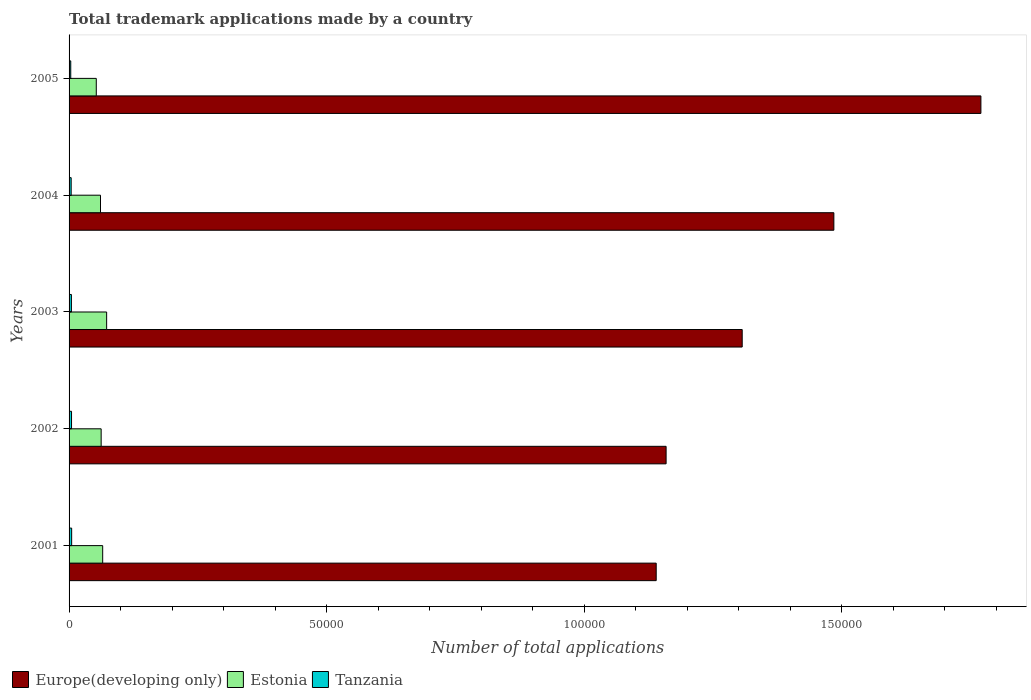How many different coloured bars are there?
Your answer should be compact. 3. How many groups of bars are there?
Give a very brief answer. 5. Are the number of bars per tick equal to the number of legend labels?
Give a very brief answer. Yes. What is the number of applications made by in Europe(developing only) in 2001?
Ensure brevity in your answer.  1.14e+05. Across all years, what is the maximum number of applications made by in Estonia?
Your answer should be very brief. 7292. Across all years, what is the minimum number of applications made by in Tanzania?
Offer a terse response. 325. In which year was the number of applications made by in Europe(developing only) minimum?
Your response must be concise. 2001. What is the total number of applications made by in Tanzania in the graph?
Offer a terse response. 2165. What is the difference between the number of applications made by in Tanzania in 2001 and that in 2004?
Your answer should be compact. 94. What is the difference between the number of applications made by in Tanzania in 2003 and the number of applications made by in Estonia in 2002?
Your response must be concise. -5778. What is the average number of applications made by in Estonia per year?
Provide a short and direct response. 6286. In the year 2002, what is the difference between the number of applications made by in Tanzania and number of applications made by in Estonia?
Your response must be concise. -5752. In how many years, is the number of applications made by in Estonia greater than 130000 ?
Give a very brief answer. 0. What is the ratio of the number of applications made by in Tanzania in 2001 to that in 2003?
Make the answer very short. 1.11. Is the number of applications made by in Estonia in 2004 less than that in 2005?
Keep it short and to the point. No. Is the difference between the number of applications made by in Tanzania in 2001 and 2002 greater than the difference between the number of applications made by in Estonia in 2001 and 2002?
Your response must be concise. No. What is the difference between the highest and the second highest number of applications made by in Tanzania?
Offer a terse response. 24. What is the difference between the highest and the lowest number of applications made by in Estonia?
Provide a short and direct response. 2011. In how many years, is the number of applications made by in Tanzania greater than the average number of applications made by in Tanzania taken over all years?
Your response must be concise. 3. Is the sum of the number of applications made by in Europe(developing only) in 2003 and 2004 greater than the maximum number of applications made by in Estonia across all years?
Ensure brevity in your answer.  Yes. What does the 1st bar from the top in 2005 represents?
Keep it short and to the point. Tanzania. What does the 2nd bar from the bottom in 2005 represents?
Offer a very short reply. Estonia. Is it the case that in every year, the sum of the number of applications made by in Tanzania and number of applications made by in Estonia is greater than the number of applications made by in Europe(developing only)?
Give a very brief answer. No. What is the difference between two consecutive major ticks on the X-axis?
Provide a succinct answer. 5.00e+04. Does the graph contain any zero values?
Offer a terse response. No. Where does the legend appear in the graph?
Ensure brevity in your answer.  Bottom left. What is the title of the graph?
Provide a short and direct response. Total trademark applications made by a country. Does "Small states" appear as one of the legend labels in the graph?
Make the answer very short. No. What is the label or title of the X-axis?
Ensure brevity in your answer.  Number of total applications. What is the Number of total applications of Europe(developing only) in 2001?
Your response must be concise. 1.14e+05. What is the Number of total applications in Estonia in 2001?
Offer a terse response. 6527. What is the Number of total applications in Tanzania in 2001?
Give a very brief answer. 502. What is the Number of total applications of Europe(developing only) in 2002?
Your answer should be compact. 1.16e+05. What is the Number of total applications of Estonia in 2002?
Provide a succinct answer. 6230. What is the Number of total applications in Tanzania in 2002?
Ensure brevity in your answer.  478. What is the Number of total applications in Europe(developing only) in 2003?
Offer a terse response. 1.31e+05. What is the Number of total applications of Estonia in 2003?
Give a very brief answer. 7292. What is the Number of total applications in Tanzania in 2003?
Keep it short and to the point. 452. What is the Number of total applications in Europe(developing only) in 2004?
Ensure brevity in your answer.  1.48e+05. What is the Number of total applications of Estonia in 2004?
Give a very brief answer. 6100. What is the Number of total applications in Tanzania in 2004?
Ensure brevity in your answer.  408. What is the Number of total applications in Europe(developing only) in 2005?
Make the answer very short. 1.77e+05. What is the Number of total applications of Estonia in 2005?
Make the answer very short. 5281. What is the Number of total applications in Tanzania in 2005?
Your answer should be compact. 325. Across all years, what is the maximum Number of total applications in Europe(developing only)?
Offer a terse response. 1.77e+05. Across all years, what is the maximum Number of total applications in Estonia?
Provide a succinct answer. 7292. Across all years, what is the maximum Number of total applications of Tanzania?
Make the answer very short. 502. Across all years, what is the minimum Number of total applications in Europe(developing only)?
Your answer should be compact. 1.14e+05. Across all years, what is the minimum Number of total applications in Estonia?
Provide a short and direct response. 5281. Across all years, what is the minimum Number of total applications of Tanzania?
Keep it short and to the point. 325. What is the total Number of total applications of Europe(developing only) in the graph?
Your response must be concise. 6.86e+05. What is the total Number of total applications of Estonia in the graph?
Your response must be concise. 3.14e+04. What is the total Number of total applications of Tanzania in the graph?
Your answer should be very brief. 2165. What is the difference between the Number of total applications of Europe(developing only) in 2001 and that in 2002?
Give a very brief answer. -1922. What is the difference between the Number of total applications in Estonia in 2001 and that in 2002?
Make the answer very short. 297. What is the difference between the Number of total applications of Tanzania in 2001 and that in 2002?
Your answer should be compact. 24. What is the difference between the Number of total applications in Europe(developing only) in 2001 and that in 2003?
Give a very brief answer. -1.67e+04. What is the difference between the Number of total applications in Estonia in 2001 and that in 2003?
Make the answer very short. -765. What is the difference between the Number of total applications in Tanzania in 2001 and that in 2003?
Provide a short and direct response. 50. What is the difference between the Number of total applications of Europe(developing only) in 2001 and that in 2004?
Give a very brief answer. -3.45e+04. What is the difference between the Number of total applications of Estonia in 2001 and that in 2004?
Provide a succinct answer. 427. What is the difference between the Number of total applications in Tanzania in 2001 and that in 2004?
Offer a terse response. 94. What is the difference between the Number of total applications of Europe(developing only) in 2001 and that in 2005?
Provide a short and direct response. -6.30e+04. What is the difference between the Number of total applications in Estonia in 2001 and that in 2005?
Your answer should be very brief. 1246. What is the difference between the Number of total applications of Tanzania in 2001 and that in 2005?
Give a very brief answer. 177. What is the difference between the Number of total applications in Europe(developing only) in 2002 and that in 2003?
Give a very brief answer. -1.48e+04. What is the difference between the Number of total applications in Estonia in 2002 and that in 2003?
Keep it short and to the point. -1062. What is the difference between the Number of total applications of Tanzania in 2002 and that in 2003?
Your answer should be very brief. 26. What is the difference between the Number of total applications of Europe(developing only) in 2002 and that in 2004?
Provide a succinct answer. -3.26e+04. What is the difference between the Number of total applications in Estonia in 2002 and that in 2004?
Offer a terse response. 130. What is the difference between the Number of total applications of Tanzania in 2002 and that in 2004?
Offer a terse response. 70. What is the difference between the Number of total applications of Europe(developing only) in 2002 and that in 2005?
Offer a very short reply. -6.11e+04. What is the difference between the Number of total applications of Estonia in 2002 and that in 2005?
Offer a very short reply. 949. What is the difference between the Number of total applications in Tanzania in 2002 and that in 2005?
Ensure brevity in your answer.  153. What is the difference between the Number of total applications in Europe(developing only) in 2003 and that in 2004?
Offer a very short reply. -1.78e+04. What is the difference between the Number of total applications of Estonia in 2003 and that in 2004?
Give a very brief answer. 1192. What is the difference between the Number of total applications in Europe(developing only) in 2003 and that in 2005?
Offer a very short reply. -4.63e+04. What is the difference between the Number of total applications in Estonia in 2003 and that in 2005?
Provide a short and direct response. 2011. What is the difference between the Number of total applications of Tanzania in 2003 and that in 2005?
Offer a very short reply. 127. What is the difference between the Number of total applications of Europe(developing only) in 2004 and that in 2005?
Offer a terse response. -2.85e+04. What is the difference between the Number of total applications in Estonia in 2004 and that in 2005?
Offer a very short reply. 819. What is the difference between the Number of total applications in Europe(developing only) in 2001 and the Number of total applications in Estonia in 2002?
Your answer should be very brief. 1.08e+05. What is the difference between the Number of total applications in Europe(developing only) in 2001 and the Number of total applications in Tanzania in 2002?
Keep it short and to the point. 1.13e+05. What is the difference between the Number of total applications of Estonia in 2001 and the Number of total applications of Tanzania in 2002?
Ensure brevity in your answer.  6049. What is the difference between the Number of total applications of Europe(developing only) in 2001 and the Number of total applications of Estonia in 2003?
Your response must be concise. 1.07e+05. What is the difference between the Number of total applications of Europe(developing only) in 2001 and the Number of total applications of Tanzania in 2003?
Your response must be concise. 1.14e+05. What is the difference between the Number of total applications of Estonia in 2001 and the Number of total applications of Tanzania in 2003?
Give a very brief answer. 6075. What is the difference between the Number of total applications in Europe(developing only) in 2001 and the Number of total applications in Estonia in 2004?
Your answer should be compact. 1.08e+05. What is the difference between the Number of total applications in Europe(developing only) in 2001 and the Number of total applications in Tanzania in 2004?
Ensure brevity in your answer.  1.14e+05. What is the difference between the Number of total applications in Estonia in 2001 and the Number of total applications in Tanzania in 2004?
Keep it short and to the point. 6119. What is the difference between the Number of total applications in Europe(developing only) in 2001 and the Number of total applications in Estonia in 2005?
Provide a short and direct response. 1.09e+05. What is the difference between the Number of total applications of Europe(developing only) in 2001 and the Number of total applications of Tanzania in 2005?
Offer a very short reply. 1.14e+05. What is the difference between the Number of total applications in Estonia in 2001 and the Number of total applications in Tanzania in 2005?
Offer a very short reply. 6202. What is the difference between the Number of total applications in Europe(developing only) in 2002 and the Number of total applications in Estonia in 2003?
Your answer should be very brief. 1.09e+05. What is the difference between the Number of total applications of Europe(developing only) in 2002 and the Number of total applications of Tanzania in 2003?
Offer a terse response. 1.15e+05. What is the difference between the Number of total applications of Estonia in 2002 and the Number of total applications of Tanzania in 2003?
Provide a short and direct response. 5778. What is the difference between the Number of total applications of Europe(developing only) in 2002 and the Number of total applications of Estonia in 2004?
Offer a terse response. 1.10e+05. What is the difference between the Number of total applications of Europe(developing only) in 2002 and the Number of total applications of Tanzania in 2004?
Provide a succinct answer. 1.15e+05. What is the difference between the Number of total applications of Estonia in 2002 and the Number of total applications of Tanzania in 2004?
Provide a short and direct response. 5822. What is the difference between the Number of total applications in Europe(developing only) in 2002 and the Number of total applications in Estonia in 2005?
Ensure brevity in your answer.  1.11e+05. What is the difference between the Number of total applications of Europe(developing only) in 2002 and the Number of total applications of Tanzania in 2005?
Give a very brief answer. 1.16e+05. What is the difference between the Number of total applications of Estonia in 2002 and the Number of total applications of Tanzania in 2005?
Make the answer very short. 5905. What is the difference between the Number of total applications of Europe(developing only) in 2003 and the Number of total applications of Estonia in 2004?
Keep it short and to the point. 1.25e+05. What is the difference between the Number of total applications of Europe(developing only) in 2003 and the Number of total applications of Tanzania in 2004?
Provide a short and direct response. 1.30e+05. What is the difference between the Number of total applications of Estonia in 2003 and the Number of total applications of Tanzania in 2004?
Give a very brief answer. 6884. What is the difference between the Number of total applications of Europe(developing only) in 2003 and the Number of total applications of Estonia in 2005?
Your answer should be very brief. 1.25e+05. What is the difference between the Number of total applications in Europe(developing only) in 2003 and the Number of total applications in Tanzania in 2005?
Give a very brief answer. 1.30e+05. What is the difference between the Number of total applications of Estonia in 2003 and the Number of total applications of Tanzania in 2005?
Provide a short and direct response. 6967. What is the difference between the Number of total applications in Europe(developing only) in 2004 and the Number of total applications in Estonia in 2005?
Your answer should be very brief. 1.43e+05. What is the difference between the Number of total applications in Europe(developing only) in 2004 and the Number of total applications in Tanzania in 2005?
Offer a very short reply. 1.48e+05. What is the difference between the Number of total applications of Estonia in 2004 and the Number of total applications of Tanzania in 2005?
Keep it short and to the point. 5775. What is the average Number of total applications in Europe(developing only) per year?
Your answer should be very brief. 1.37e+05. What is the average Number of total applications of Estonia per year?
Your answer should be very brief. 6286. What is the average Number of total applications of Tanzania per year?
Your response must be concise. 433. In the year 2001, what is the difference between the Number of total applications of Europe(developing only) and Number of total applications of Estonia?
Your response must be concise. 1.07e+05. In the year 2001, what is the difference between the Number of total applications of Europe(developing only) and Number of total applications of Tanzania?
Your answer should be compact. 1.13e+05. In the year 2001, what is the difference between the Number of total applications in Estonia and Number of total applications in Tanzania?
Give a very brief answer. 6025. In the year 2002, what is the difference between the Number of total applications of Europe(developing only) and Number of total applications of Estonia?
Your response must be concise. 1.10e+05. In the year 2002, what is the difference between the Number of total applications in Europe(developing only) and Number of total applications in Tanzania?
Keep it short and to the point. 1.15e+05. In the year 2002, what is the difference between the Number of total applications of Estonia and Number of total applications of Tanzania?
Keep it short and to the point. 5752. In the year 2003, what is the difference between the Number of total applications of Europe(developing only) and Number of total applications of Estonia?
Your response must be concise. 1.23e+05. In the year 2003, what is the difference between the Number of total applications in Europe(developing only) and Number of total applications in Tanzania?
Provide a succinct answer. 1.30e+05. In the year 2003, what is the difference between the Number of total applications of Estonia and Number of total applications of Tanzania?
Provide a short and direct response. 6840. In the year 2004, what is the difference between the Number of total applications in Europe(developing only) and Number of total applications in Estonia?
Ensure brevity in your answer.  1.42e+05. In the year 2004, what is the difference between the Number of total applications of Europe(developing only) and Number of total applications of Tanzania?
Your answer should be very brief. 1.48e+05. In the year 2004, what is the difference between the Number of total applications of Estonia and Number of total applications of Tanzania?
Provide a succinct answer. 5692. In the year 2005, what is the difference between the Number of total applications in Europe(developing only) and Number of total applications in Estonia?
Your answer should be compact. 1.72e+05. In the year 2005, what is the difference between the Number of total applications of Europe(developing only) and Number of total applications of Tanzania?
Give a very brief answer. 1.77e+05. In the year 2005, what is the difference between the Number of total applications of Estonia and Number of total applications of Tanzania?
Your response must be concise. 4956. What is the ratio of the Number of total applications in Europe(developing only) in 2001 to that in 2002?
Your answer should be compact. 0.98. What is the ratio of the Number of total applications in Estonia in 2001 to that in 2002?
Ensure brevity in your answer.  1.05. What is the ratio of the Number of total applications of Tanzania in 2001 to that in 2002?
Offer a very short reply. 1.05. What is the ratio of the Number of total applications in Europe(developing only) in 2001 to that in 2003?
Give a very brief answer. 0.87. What is the ratio of the Number of total applications in Estonia in 2001 to that in 2003?
Make the answer very short. 0.9. What is the ratio of the Number of total applications of Tanzania in 2001 to that in 2003?
Give a very brief answer. 1.11. What is the ratio of the Number of total applications in Europe(developing only) in 2001 to that in 2004?
Make the answer very short. 0.77. What is the ratio of the Number of total applications in Estonia in 2001 to that in 2004?
Your answer should be very brief. 1.07. What is the ratio of the Number of total applications of Tanzania in 2001 to that in 2004?
Provide a succinct answer. 1.23. What is the ratio of the Number of total applications in Europe(developing only) in 2001 to that in 2005?
Make the answer very short. 0.64. What is the ratio of the Number of total applications in Estonia in 2001 to that in 2005?
Give a very brief answer. 1.24. What is the ratio of the Number of total applications in Tanzania in 2001 to that in 2005?
Your answer should be very brief. 1.54. What is the ratio of the Number of total applications of Europe(developing only) in 2002 to that in 2003?
Offer a very short reply. 0.89. What is the ratio of the Number of total applications of Estonia in 2002 to that in 2003?
Your answer should be very brief. 0.85. What is the ratio of the Number of total applications in Tanzania in 2002 to that in 2003?
Your answer should be compact. 1.06. What is the ratio of the Number of total applications in Europe(developing only) in 2002 to that in 2004?
Give a very brief answer. 0.78. What is the ratio of the Number of total applications of Estonia in 2002 to that in 2004?
Offer a terse response. 1.02. What is the ratio of the Number of total applications of Tanzania in 2002 to that in 2004?
Provide a short and direct response. 1.17. What is the ratio of the Number of total applications in Europe(developing only) in 2002 to that in 2005?
Your response must be concise. 0.65. What is the ratio of the Number of total applications of Estonia in 2002 to that in 2005?
Provide a succinct answer. 1.18. What is the ratio of the Number of total applications of Tanzania in 2002 to that in 2005?
Your response must be concise. 1.47. What is the ratio of the Number of total applications in Europe(developing only) in 2003 to that in 2004?
Your answer should be very brief. 0.88. What is the ratio of the Number of total applications in Estonia in 2003 to that in 2004?
Offer a very short reply. 1.2. What is the ratio of the Number of total applications of Tanzania in 2003 to that in 2004?
Keep it short and to the point. 1.11. What is the ratio of the Number of total applications in Europe(developing only) in 2003 to that in 2005?
Provide a succinct answer. 0.74. What is the ratio of the Number of total applications in Estonia in 2003 to that in 2005?
Keep it short and to the point. 1.38. What is the ratio of the Number of total applications in Tanzania in 2003 to that in 2005?
Provide a succinct answer. 1.39. What is the ratio of the Number of total applications of Europe(developing only) in 2004 to that in 2005?
Your response must be concise. 0.84. What is the ratio of the Number of total applications in Estonia in 2004 to that in 2005?
Ensure brevity in your answer.  1.16. What is the ratio of the Number of total applications in Tanzania in 2004 to that in 2005?
Your answer should be very brief. 1.26. What is the difference between the highest and the second highest Number of total applications of Europe(developing only)?
Your answer should be very brief. 2.85e+04. What is the difference between the highest and the second highest Number of total applications of Estonia?
Offer a terse response. 765. What is the difference between the highest and the lowest Number of total applications in Europe(developing only)?
Your response must be concise. 6.30e+04. What is the difference between the highest and the lowest Number of total applications in Estonia?
Your response must be concise. 2011. What is the difference between the highest and the lowest Number of total applications in Tanzania?
Your answer should be very brief. 177. 